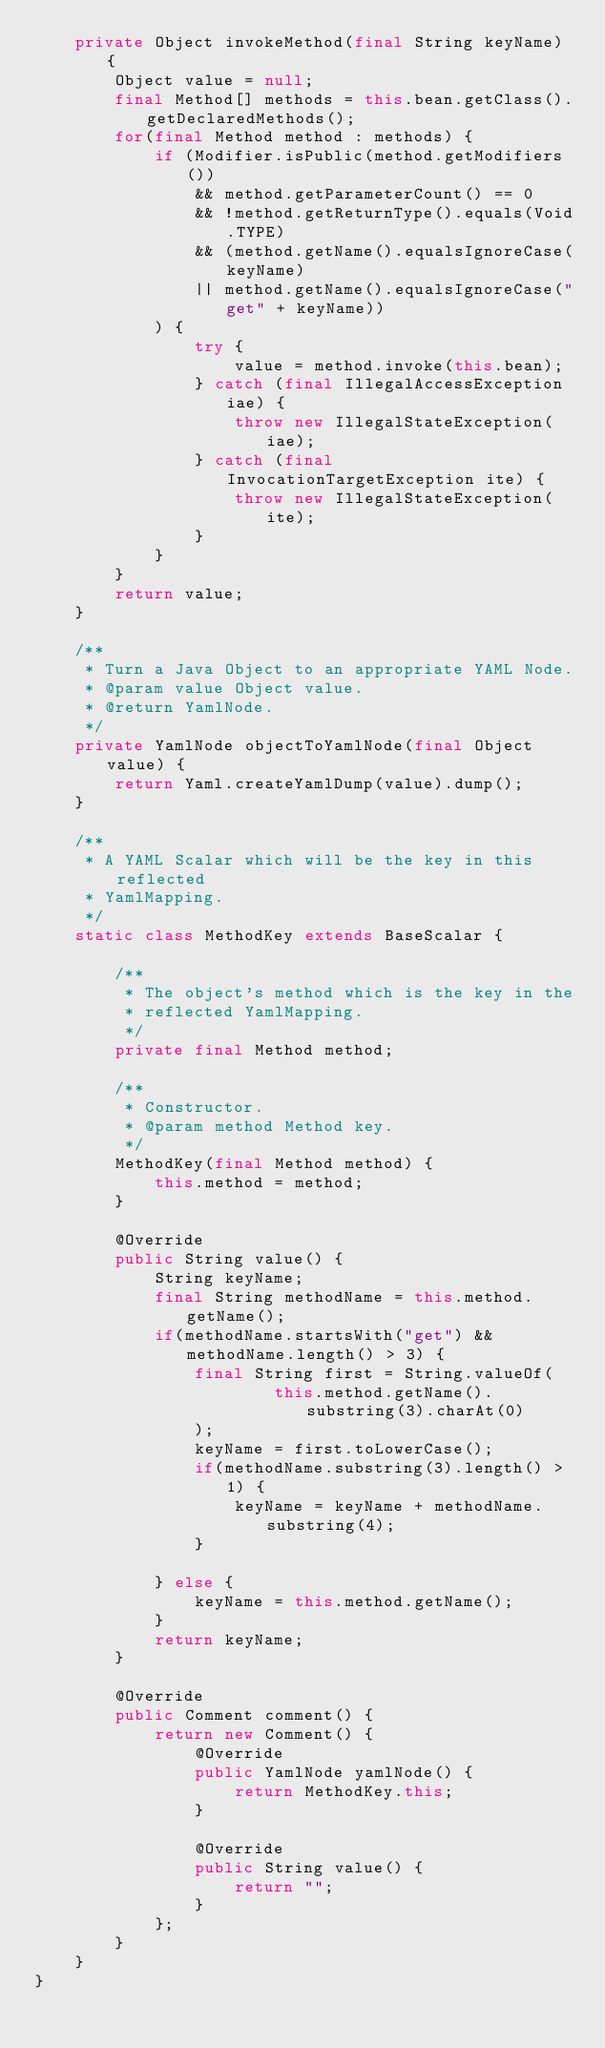<code> <loc_0><loc_0><loc_500><loc_500><_Java_>    private Object invokeMethod(final String keyName) {
        Object value = null;
        final Method[] methods = this.bean.getClass().getDeclaredMethods();
        for(final Method method : methods) {
            if (Modifier.isPublic(method.getModifiers())
                && method.getParameterCount() == 0
                && !method.getReturnType().equals(Void.TYPE)
                && (method.getName().equalsIgnoreCase(keyName)
                || method.getName().equalsIgnoreCase("get" + keyName))
            ) {
                try {
                    value = method.invoke(this.bean);
                } catch (final IllegalAccessException iae) {
                    throw new IllegalStateException(iae);
                } catch (final InvocationTargetException ite) {
                    throw new IllegalStateException(ite);
                }
            }
        }
        return value;
    }

    /**
     * Turn a Java Object to an appropriate YAML Node.
     * @param value Object value.
     * @return YamlNode.
     */
    private YamlNode objectToYamlNode(final Object value) {
        return Yaml.createYamlDump(value).dump();
    }

    /**
     * A YAML Scalar which will be the key in this reflected
     * YamlMapping.
     */
    static class MethodKey extends BaseScalar {

        /**
         * The object's method which is the key in the
         * reflected YamlMapping.
         */
        private final Method method;

        /**
         * Constructor.
         * @param method Method key.
         */
        MethodKey(final Method method) {
            this.method = method;
        }

        @Override
        public String value() {
            String keyName;
            final String methodName = this.method.getName();
            if(methodName.startsWith("get") && methodName.length() > 3) {
                final String first = String.valueOf(
                        this.method.getName().substring(3).charAt(0)
                );
                keyName = first.toLowerCase();
                if(methodName.substring(3).length() > 1) {
                    keyName = keyName + methodName.substring(4);
                }

            } else {
                keyName = this.method.getName();
            }
            return keyName;
        }

        @Override
        public Comment comment() {
            return new Comment() {
                @Override
                public YamlNode yamlNode() {
                    return MethodKey.this;
                }

                @Override
                public String value() {
                    return "";
                }
            };
        }
    }
}
</code> 